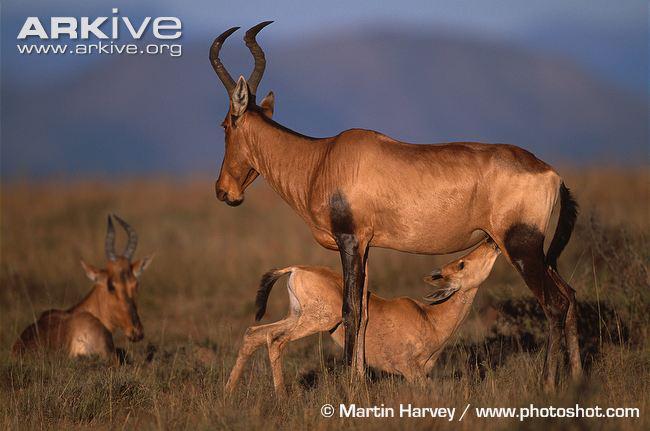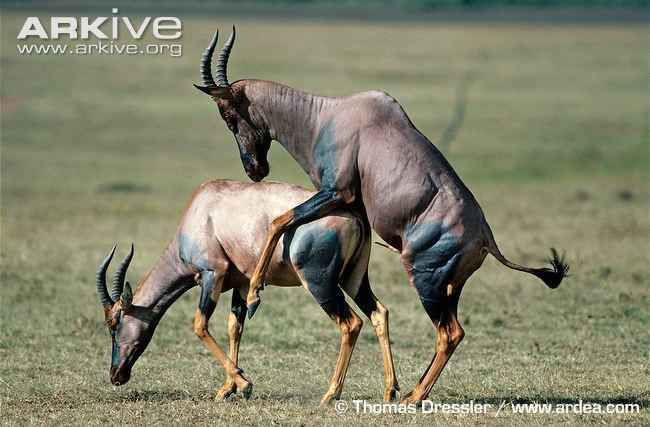The first image is the image on the left, the second image is the image on the right. Assess this claim about the two images: "The right image shows one horned animal standing behind another horned animal, with its front legs wrapped around the animal's back.". Correct or not? Answer yes or no. Yes. The first image is the image on the left, the second image is the image on the right. For the images displayed, is the sentence "The left and right image contains a total of three antelope." factually correct? Answer yes or no. No. 